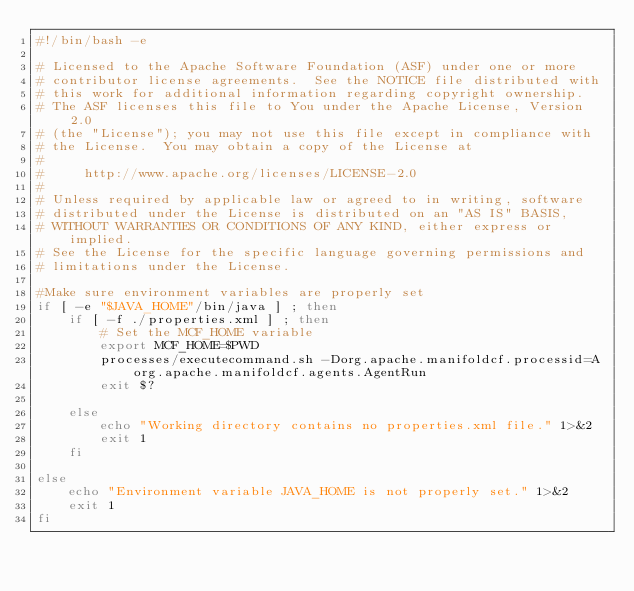Convert code to text. <code><loc_0><loc_0><loc_500><loc_500><_Bash_>#!/bin/bash -e

# Licensed to the Apache Software Foundation (ASF) under one or more
# contributor license agreements.  See the NOTICE file distributed with
# this work for additional information regarding copyright ownership.
# The ASF licenses this file to You under the Apache License, Version 2.0
# (the "License"); you may not use this file except in compliance with
# the License.  You may obtain a copy of the License at
#
#     http://www.apache.org/licenses/LICENSE-2.0
#
# Unless required by applicable law or agreed to in writing, software
# distributed under the License is distributed on an "AS IS" BASIS,
# WITHOUT WARRANTIES OR CONDITIONS OF ANY KIND, either express or implied.
# See the License for the specific language governing permissions and
# limitations under the License.

#Make sure environment variables are properly set
if [ -e "$JAVA_HOME"/bin/java ] ; then
    if [ -f ./properties.xml ] ; then
        # Set the MCF_HOME variable
        export MCF_HOME=$PWD
        processes/executecommand.sh -Dorg.apache.manifoldcf.processid=A org.apache.manifoldcf.agents.AgentRun
        exit $?
        
    else
        echo "Working directory contains no properties.xml file." 1>&2
        exit 1
    fi
    
else
    echo "Environment variable JAVA_HOME is not properly set." 1>&2
    exit 1
fi
</code> 